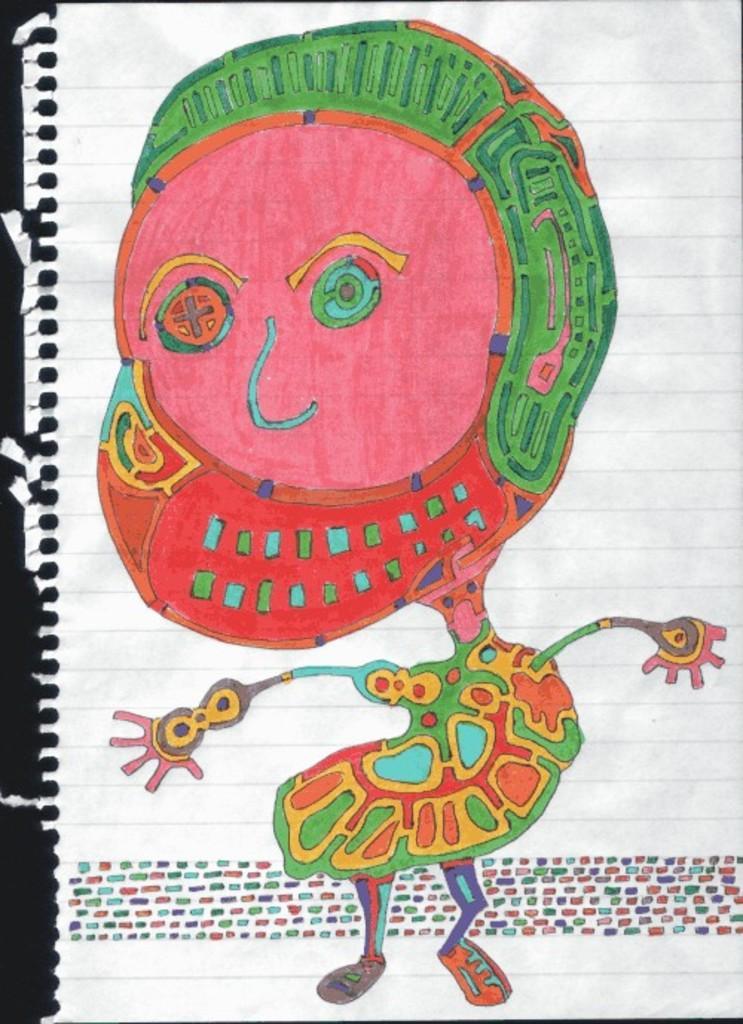In one or two sentences, can you explain what this image depicts? In this picture we can see one paper on it one picture is drawn and filled with colors. 